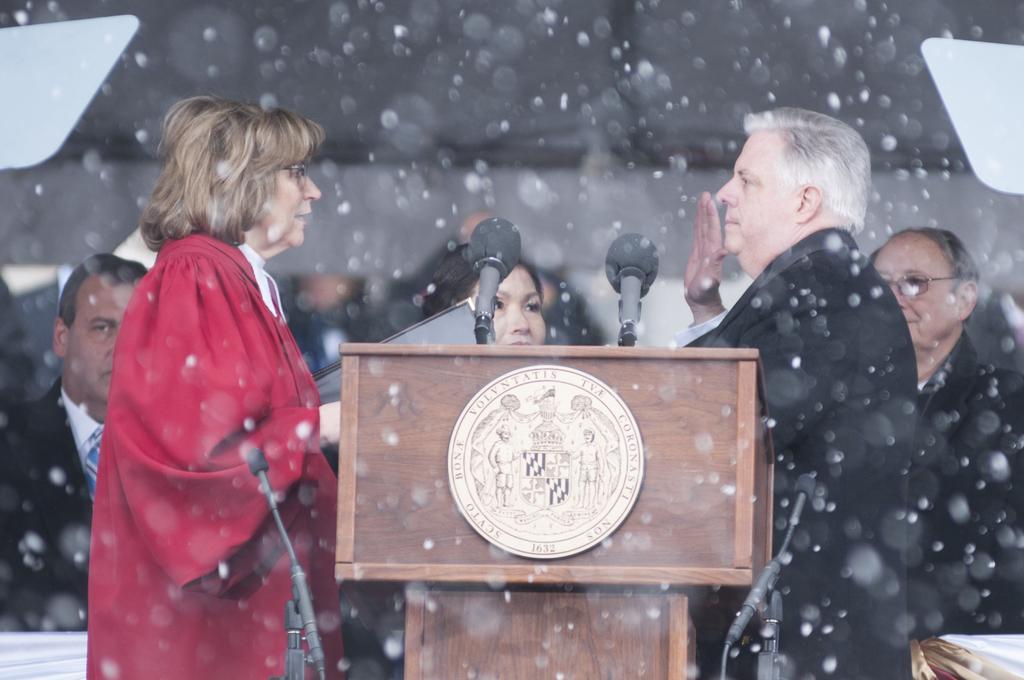Could you give a brief overview of what you see in this image? There are some people standing. A lady in red dress is holding something in the hand. There is a podium. On that there are mics. On the podium there are mics. On the podium there is a logo. Also there are other mics with stands. 